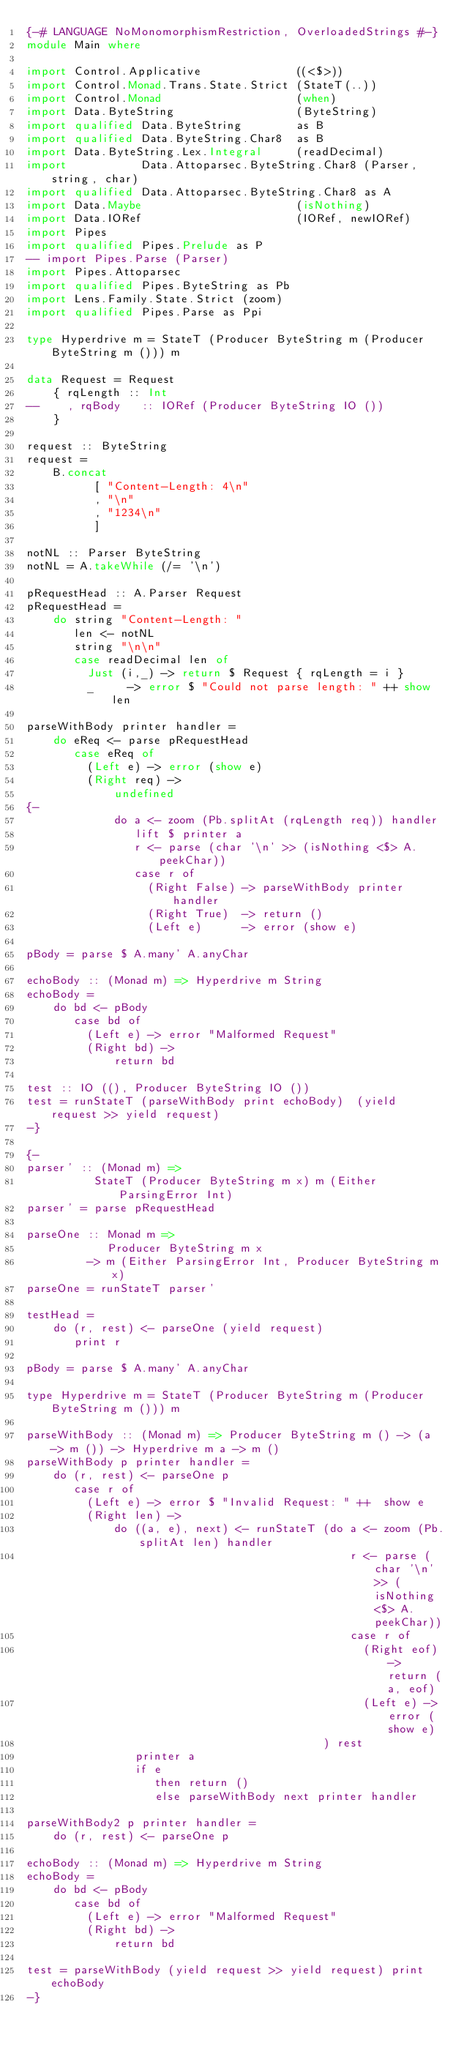Convert code to text. <code><loc_0><loc_0><loc_500><loc_500><_Haskell_>{-# LANGUAGE NoMonomorphismRestriction, OverloadedStrings #-}
module Main where

import Control.Applicative              ((<$>))
import Control.Monad.Trans.State.Strict (StateT(..))
import Control.Monad                    (when)
import Data.ByteString                  (ByteString)
import qualified Data.ByteString        as B
import qualified Data.ByteString.Char8  as B
import Data.ByteString.Lex.Integral     (readDecimal)
import           Data.Attoparsec.ByteString.Char8 (Parser, string, char)
import qualified Data.Attoparsec.ByteString.Char8 as A
import Data.Maybe                       (isNothing)
import Data.IORef                       (IORef, newIORef)
import Pipes
import qualified Pipes.Prelude as P
-- import Pipes.Parse (Parser)
import Pipes.Attoparsec
import qualified Pipes.ByteString as Pb
import Lens.Family.State.Strict (zoom)
import qualified Pipes.Parse as Ppi

type Hyperdrive m = StateT (Producer ByteString m (Producer ByteString m ())) m

data Request = Request
    { rqLength :: Int
--    , rqBody   :: IORef (Producer ByteString IO ())
    }

request :: ByteString
request =
    B.concat
          [ "Content-Length: 4\n"
          , "\n"
          , "1234\n"
          ]

notNL :: Parser ByteString
notNL = A.takeWhile (/= '\n')

pRequestHead :: A.Parser Request
pRequestHead =
    do string "Content-Length: "
       len <- notNL
       string "\n\n"
       case readDecimal len of
         Just (i,_) -> return $ Request { rqLength = i }
         _     -> error $ "Could not parse length: " ++ show len

parseWithBody printer handler =
    do eReq <- parse pRequestHead
       case eReq of
         (Left e) -> error (show e)
         (Right req) ->
             undefined
{-
             do a <- zoom (Pb.splitAt (rqLength req)) handler
                lift $ printer a
                r <- parse (char '\n' >> (isNothing <$> A.peekChar))
                case r of
                  (Right False) -> parseWithBody printer handler
                  (Right True)  -> return ()
                  (Left e)      -> error (show e)

pBody = parse $ A.many' A.anyChar

echoBody :: (Monad m) => Hyperdrive m String
echoBody =
    do bd <- pBody
       case bd of
         (Left e) -> error "Malformed Request"
         (Right bd) ->
             return bd

test :: IO ((), Producer ByteString IO ())
test = runStateT (parseWithBody print echoBody)  (yield request >> yield request) 
-}

{-
parser' :: (Monad m) =>
          StateT (Producer ByteString m x) m (Either ParsingError Int)
parser' = parse pRequestHead

parseOne :: Monad m =>
            Producer ByteString m x
         -> m (Either ParsingError Int, Producer ByteString m x)
parseOne = runStateT parser'

testHead =
    do (r, rest) <- parseOne (yield request)
       print r

pBody = parse $ A.many' A.anyChar

type Hyperdrive m = StateT (Producer ByteString m (Producer ByteString m ())) m

parseWithBody :: (Monad m) => Producer ByteString m () -> (a -> m ()) -> Hyperdrive m a -> m ()
parseWithBody p printer handler =
    do (r, rest) <- parseOne p
       case r of
         (Left e) -> error $ "Invalid Request: " ++  show e
         (Right len) ->
             do ((a, e), next) <- runStateT (do a <- zoom (Pb.splitAt len) handler
                                                r <- parse (char '\n' >> (isNothing <$> A.peekChar))
                                                case r of
                                                  (Right eof) -> return (a, eof)
                                                  (Left e) -> error (show e)
                                            ) rest
                printer a
                if e
                   then return ()
                   else parseWithBody next printer handler

parseWithBody2 p printer handler =
    do (r, rest) <- parseOne p

echoBody :: (Monad m) => Hyperdrive m String
echoBody =
    do bd <- pBody
       case bd of
         (Left e) -> error "Malformed Request"
         (Right bd) ->
             return bd

test = parseWithBody (yield request >> yield request) print echoBody
-}</code> 